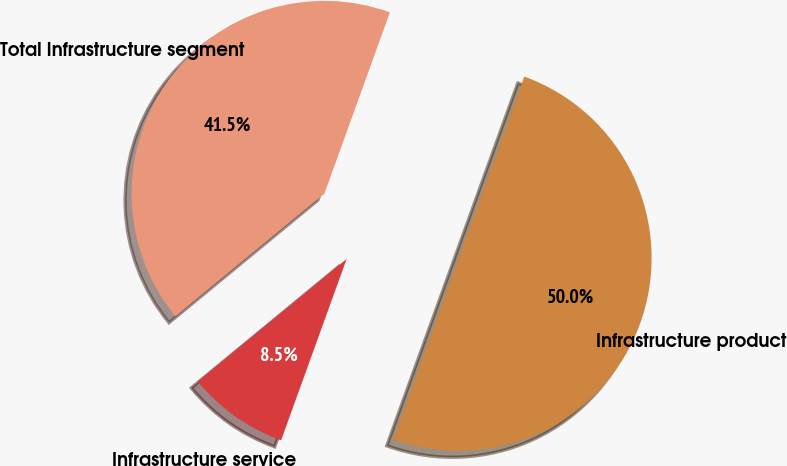<chart> <loc_0><loc_0><loc_500><loc_500><pie_chart><fcel>Infrastructure product<fcel>Infrastructure service<fcel>Total Infrastructure segment<nl><fcel>50.0%<fcel>8.52%<fcel>41.48%<nl></chart> 